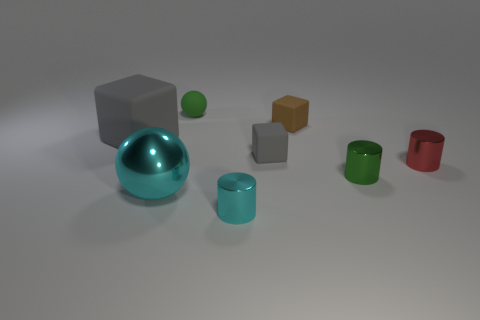What materials do the objects look like they're made of? The objects appear to be made of different materials. The grey cube and the orange cube look like they might be made of a matte plastic or metal. The turquoise sphere has a reflective surface, suggesting it could be a polished metal or glass. The green sphere and the cylinders have a less reflective surface that could indicate a plastic or painted wood material. 